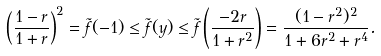Convert formula to latex. <formula><loc_0><loc_0><loc_500><loc_500>\left ( \frac { 1 - r } { 1 + r } \right ) ^ { 2 } = \tilde { f } ( - 1 ) \leq \tilde { f } ( y ) \leq \tilde { f } \left ( \frac { - 2 r } { 1 + r ^ { 2 } } \right ) = \frac { ( 1 - r ^ { 2 } ) ^ { 2 } } { 1 + 6 r ^ { 2 } + r ^ { 4 } } .</formula> 